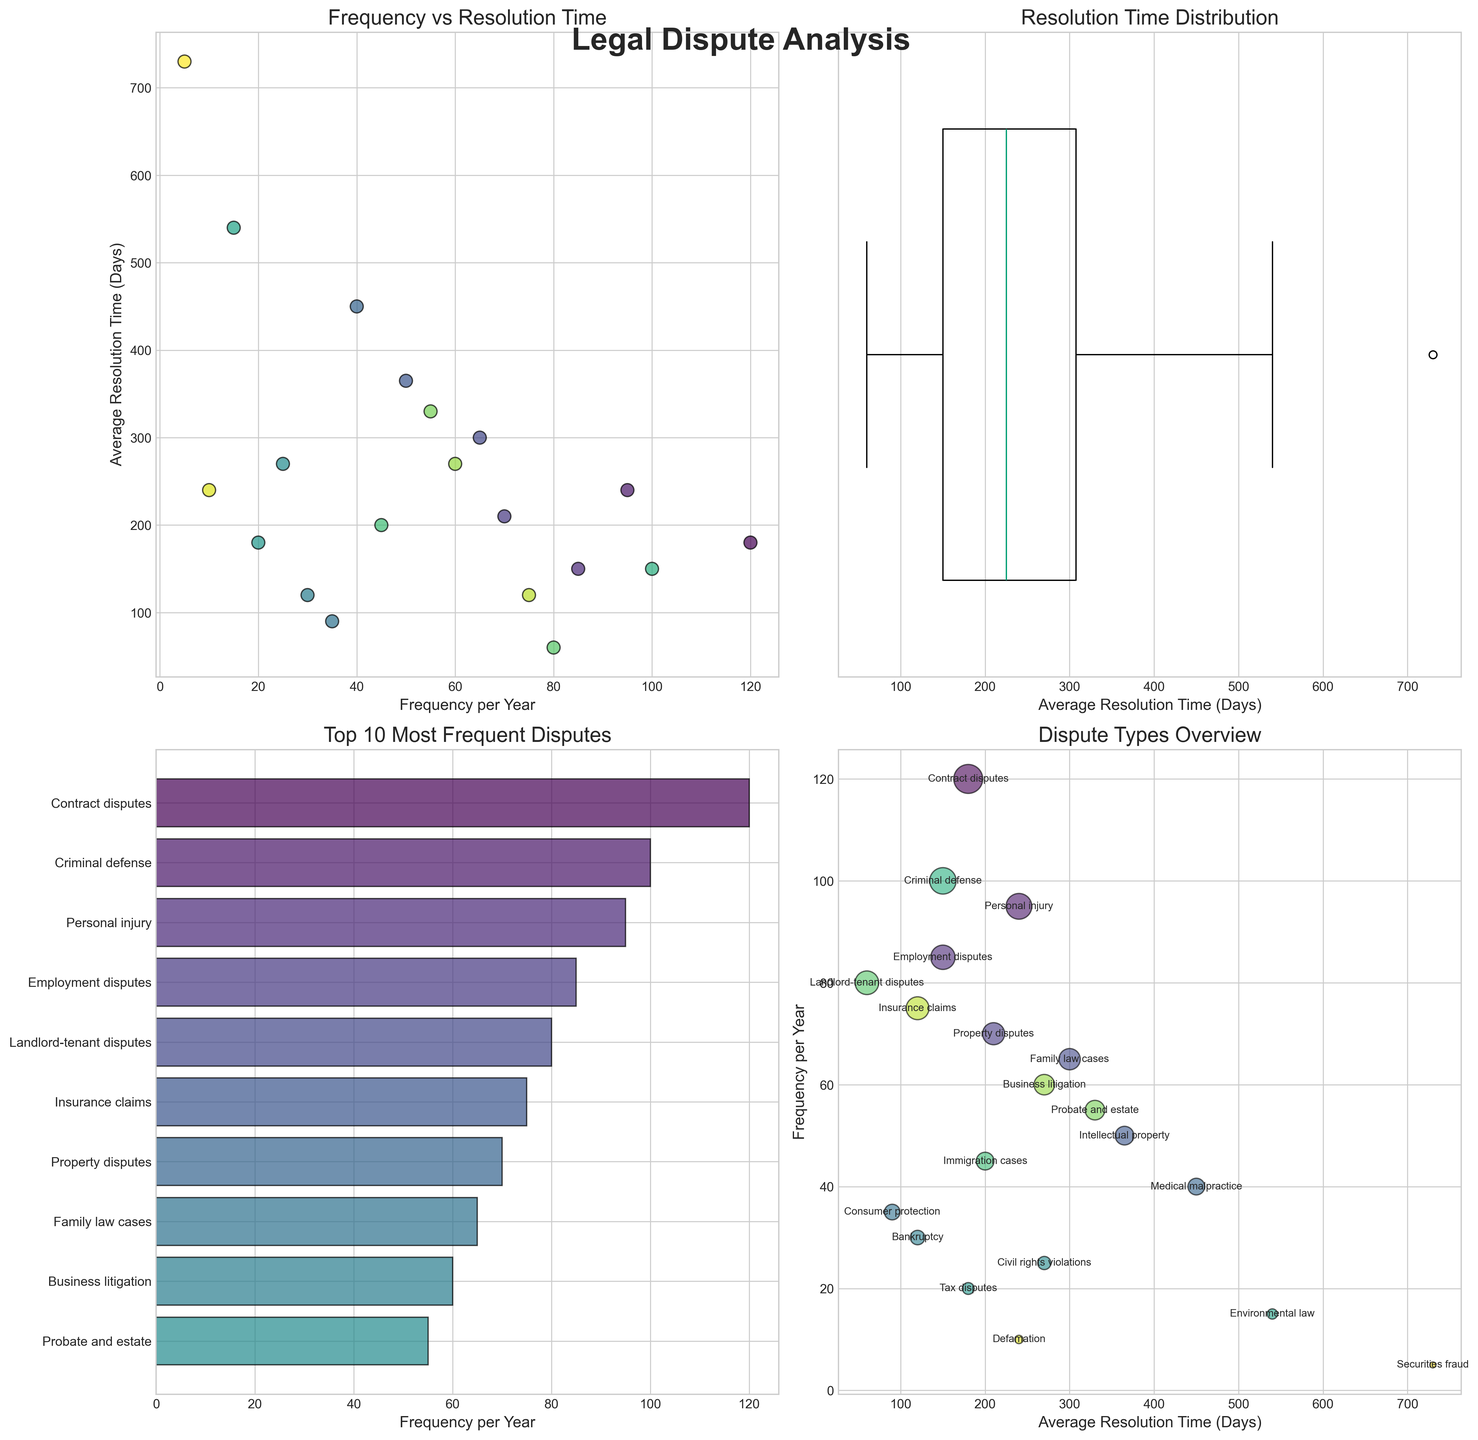What is the title of the first subplot? The title of the first subplot is shown at the top of that specific subplot, which reads "Frequency vs Resolution Time".
Answer: Frequency vs Resolution Time How many different dispute types are displayed in total? The total number of dispute types can be counted by looking at the y-axis labels in the barh plot (subplot 3), as well as each label in the bubble chart (subplot 4). There are 20 dispute types in total.
Answer: 20 Which dispute type has the shortest average resolution time? By referring to the scatter plots and bubble chart, where disputes are plotted against average resolution time, the dispute with the shortest average resolution time identified is "Landlord-tenant disputes" with 60 days.
Answer: Landlord-tenant disputes Which dispute type has the longest average resolution time? By referring to the scatter plots and bubble chart, where disputes are plotted against average resolution time, the dispute with the longest average resolution time identified is "Securities fraud" with 730 days.
Answer: Securities fraud What is the average resolution time for medical malpractice disputes as shown in the first subplot? The average resolution time for medical malpractice disputes can be found by identifying the corresponding data point in the Frequency vs Resolution Time scatter plot, which shows 450 days.
Answer: 450 days In the Top 10 Most Frequent Disputes subplot, which dispute type has the highest frequency per year? Among the top 10 disputes shown in the horizontal bar chart, "Contract disputes" have the highest frequency per year, which we can identify by following the bars and labels.
Answer: Contract disputes In the Resolution Time Distribution subplot, is the data positively skewed, negatively skewed, or symmetrical? Observing the boxplot for average resolution time in the second subplot, the longer whisker extends more to the right (higher values), indicating that the data is positively skewed.
Answer: Positively skewed Compare the average resolution times between "Personal injury" and "Intellectual property" disputes. Which one is greater and by how much? Looking at the scatter plot or bubble chart, "Intellectual property" disputes have an average resolution time of 365 days, and "Personal injury" disputes have 240 days. The difference is 365 - 240 = 125 days.
Answer: Intellectual property by 125 days How often do family law cases occur per year compared to employment disputes? By referencing the horizontal bar chart in the Top 10 Most Frequent Disputes subplot, family law cases have a frequency of 65 per year, whereas employment disputes occur 85 times per year.
Answer: Employment disputes more frequent by 20 Which dispute types are annotated in the bubble chart? In the bubble chart, annotations are provided for various dispute types plotted by average resolution time and frequency per year. Annotations include types like "Contract disputes", "Personal injury", "Employment disputes", among others.
Answer: Contract disputes, Personal injury, Employment disputes (and others) 